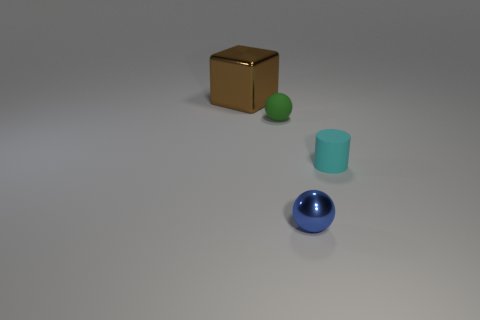Add 4 rubber spheres. How many objects exist? 8 Subtract all cubes. How many objects are left? 3 Subtract all gray things. Subtract all green balls. How many objects are left? 3 Add 3 tiny blue spheres. How many tiny blue spheres are left? 4 Add 1 tiny cyan spheres. How many tiny cyan spheres exist? 1 Subtract 0 gray spheres. How many objects are left? 4 